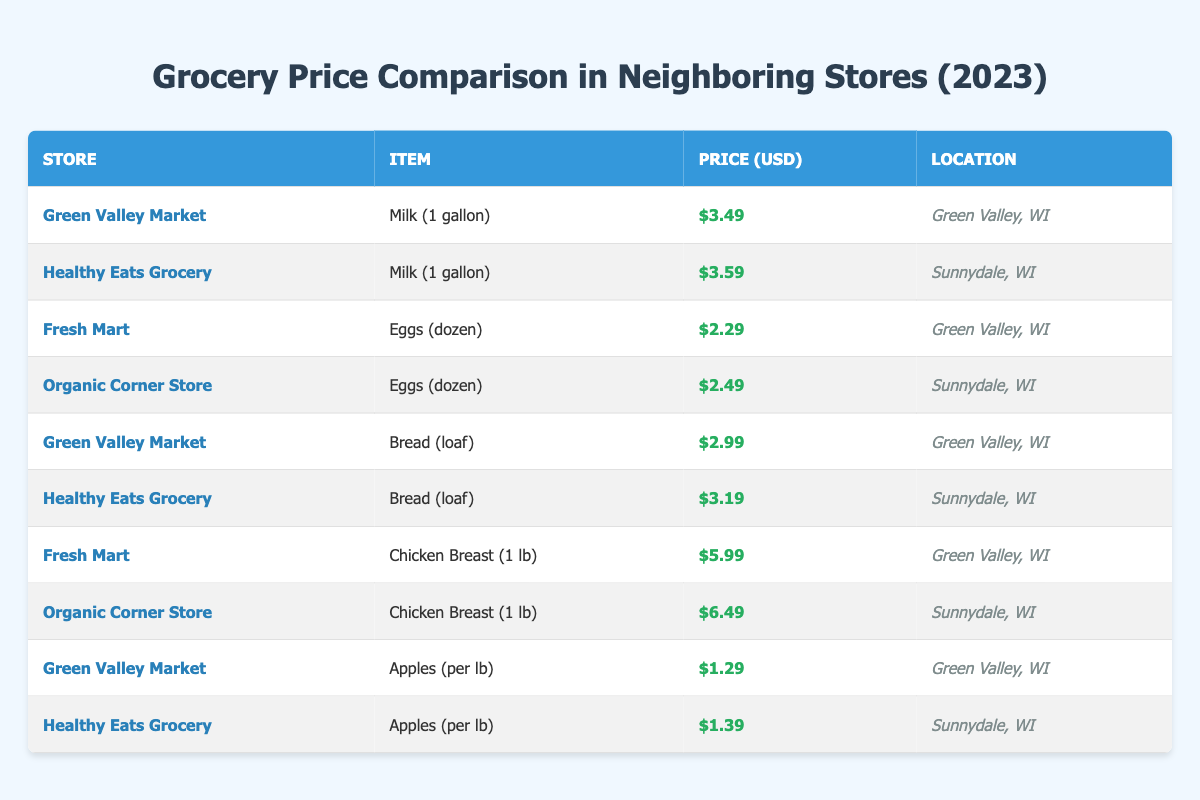What's the price of Milk (1 gallon) at Green Valley Market? The table lists Green Valley Market's price for Milk (1 gallon) as $3.49.
Answer: $3.49 Which store has the highest price for Chicken Breast (1 lb)? Looking at the prices for Chicken Breast (1 lb), Fresh Mart lists it at $5.99 and Organic Corner Store lists it at $6.49. The highest price is from Organic Corner Store.
Answer: Organic Corner Store What is the price difference between Eggs (dozen) at Fresh Mart and Organic Corner Store? Fresh Mart sells Eggs (dozen) for $2.29 while Organic Corner Store prices them at $2.49. The price difference is calculated as $2.49 - $2.29 = $0.20.
Answer: $0.20 Does Healthy Eats Grocery have cheaper prices than Green Valley Market for any item? Healthy Eats Grocery has two items listed: Milk (1 gallon) at $3.59 and Bread (loaf) at $3.19, while Green Valley Market has Milk (1 gallon) at $3.49 and Bread (loaf) at $2.99. Both items at Healthy Eats Grocery are more expensive; therefore, it does not have cheaper prices for any item.
Answer: No What are the average prices of Bread (loaf) in the two stores that sell it? Green Valley Market sells Bread (loaf) for $2.99, while Healthy Eats Grocery sells it for $3.19. To find the average price: (2.99 + 3.19) / 2 = 3.09.
Answer: $3.09 Which item is the cheapest per pound, and at which store? The prices for Apples (per lb) at Green Valley Market is $1.29 and at Healthy Eats Grocery is $1.39. The cheapest item per pound is Apples at Green Valley Market priced at $1.29.
Answer: Apples at Green Valley Market Is there any item where the price is the same at both stores? The table shows that there are no items listed at the same price in both stores; all prices differ for every item across the stores.
Answer: No If I buy two gallons of Milk from the cheapest store, how much will it cost? Green Valley Market has the lowest price for Milk (1 gallon) at $3.49. For two gallons, the total cost is 2 * $3.49 = $6.98.
Answer: $6.98 